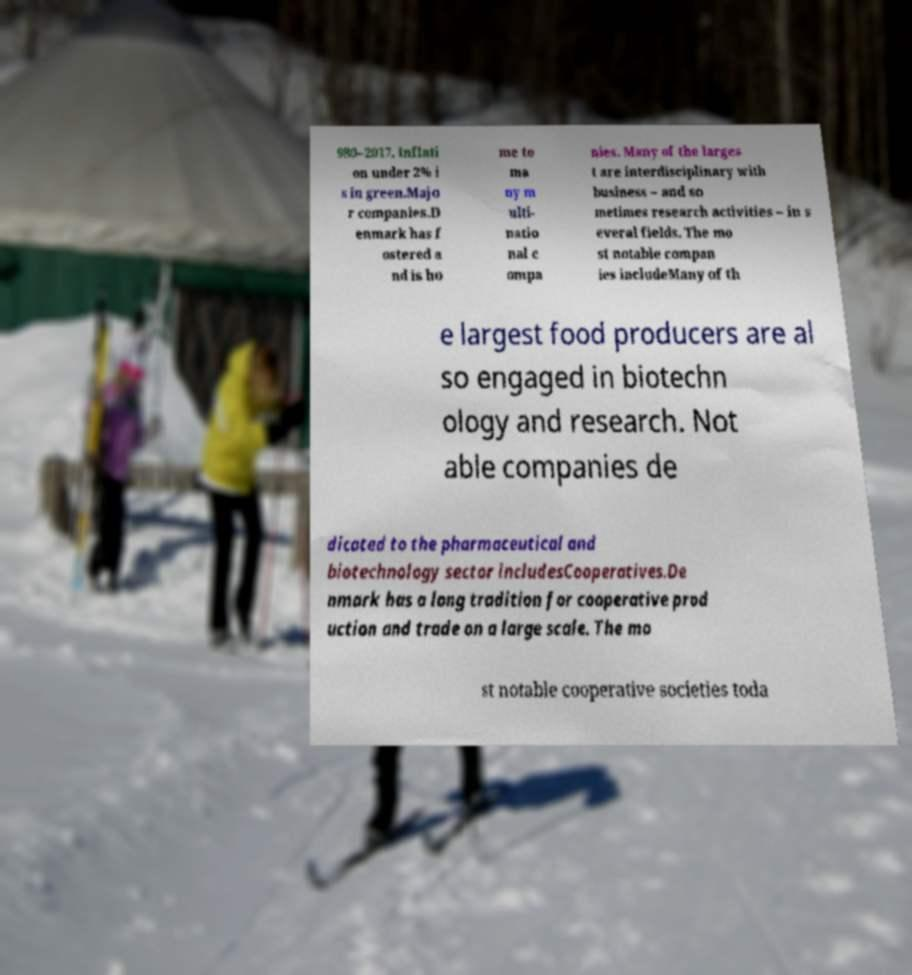Could you assist in decoding the text presented in this image and type it out clearly? 980–2017. Inflati on under 2% i s in green.Majo r companies.D enmark has f ostered a nd is ho me to ma ny m ulti- natio nal c ompa nies. Many of the larges t are interdisciplinary with business – and so metimes research activities – in s everal fields. The mo st notable compan ies includeMany of th e largest food producers are al so engaged in biotechn ology and research. Not able companies de dicated to the pharmaceutical and biotechnology sector includesCooperatives.De nmark has a long tradition for cooperative prod uction and trade on a large scale. The mo st notable cooperative societies toda 